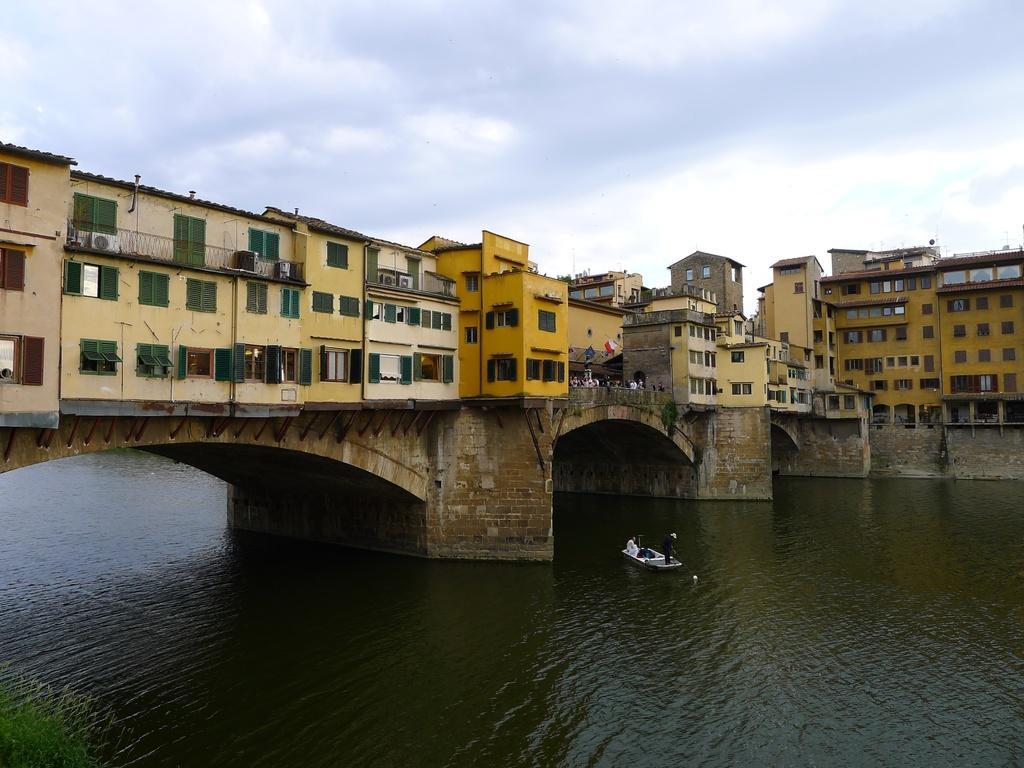Describe this image in one or two sentences. At the center of the image there are buildings on the bridge. At the bottom of the image there is a water and a boat. At the top of the image there is a sky. 